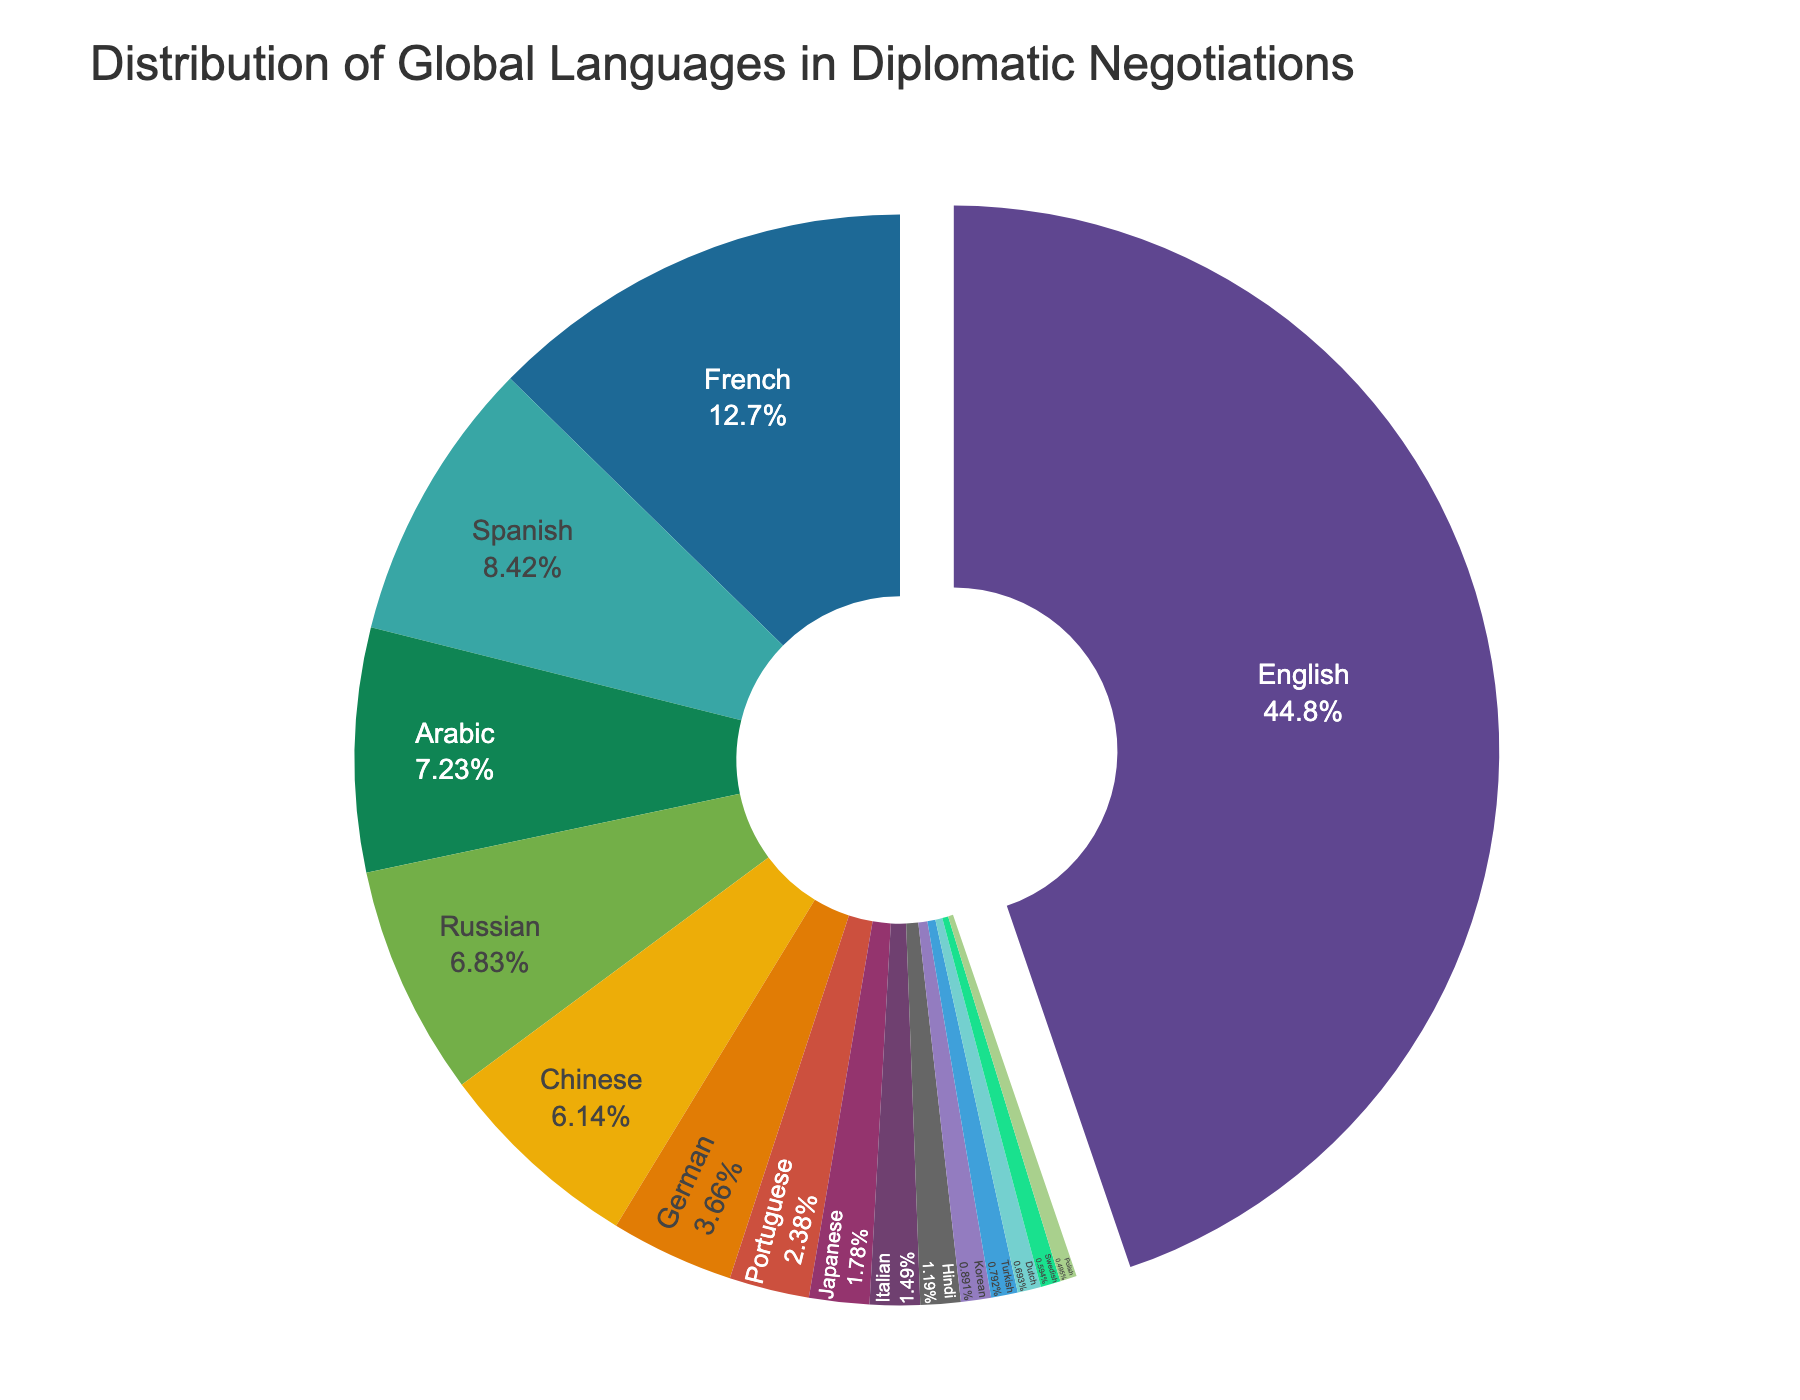Which language is the most spoken in diplomatic negotiations? From the pie chart, it is clear that English has the largest percentage at 45.2%. Therefore, English is the most spoken language in diplomatic negotiations.
Answer: English What is the combined percentage of Spanish and French in diplomatic negotiations? According to the pie chart, the percentage for Spanish is 8.5% and for French is 12.8%. Adding these together gives us 8.5% + 12.8% = 21.3%.
Answer: 21.3% Which is spoken more in diplomatic negotiations: German or Russian? The pie chart shows that German accounts for 3.7% while Russian accounts for 6.9%. Hence, Russian is spoken more in diplomatic negotiations than German.
Answer: Russian What is the difference in the percentage of usage between Arabic and Chinese in diplomatic negotiations? According to the pie chart, Arabic is at 7.3% and Chinese is at 6.2%. The difference between these two percentages is 7.3% - 6.2% = 1.1%.
Answer: 1.1% Which language accounts for the smallest percentage, and what is its value? The pie chart shows that Polish has the smallest percentage at 0.5%. Therefore, Polish is the language with the smallest percentage.
Answer: Polish (0.5%) Are Spanish, French, and Portuguese combined used more than English alone? The combined percentage for Spanish, French, and Portuguese is 8.5% + 12.8% + 2.4% = 23.7%. English alone accounts for 45.2%. Clearly, English alone is used more than the combination of Spanish, French, and Portuguese.
Answer: No What is the total percentage of languages spoken less than 5% in diplomatic negotiations? The languages spoken less than 5% are: German (3.7%), Portuguese (2.4%), Japanese (1.8%), Italian (1.5%), Hindi (1.2%), Korean (0.9%), Turkish (0.8%), Dutch (0.7%), Swedish (0.6%), and Polish (0.5%). The total percentage is 3.7% + 2.4% + 1.8% + 1.5% + 1.2% + 0.9% + 0.8% + 0.7% + 0.6% + 0.5% = 14.1%.
Answer: 14.1% Which language, other than English, has been highlighted in the pie chart and why? The visual cue of the pie chart shows that French has been pulled slightly, while English has an even more significant pull due to its highest percentage highlight. This indicates English's dominance. However, the question asks for language other than English, so the next noticeable pull is hinting at French.
Answer: French In the list of 16 languages, which language ranks fifth by the percentage used in diplomatic negotiations? From the pie chart, the percentages rank as follows: English, French, Spanish, Arabic, Russian (5th). Thus, Russian ranks fifth by percentage at 6.9%.
Answer: Russian 